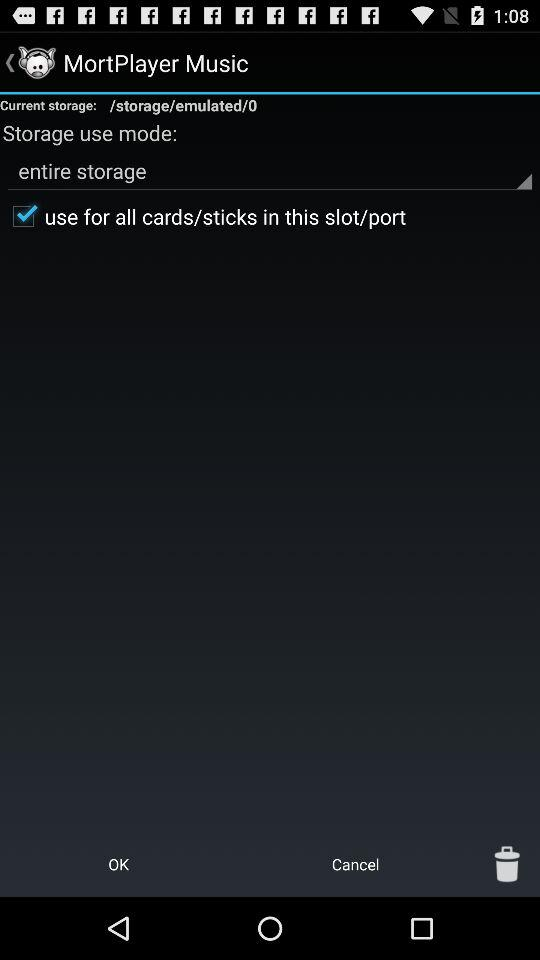How many items have been deleted?
When the provided information is insufficient, respond with <no answer>. <no answer> 